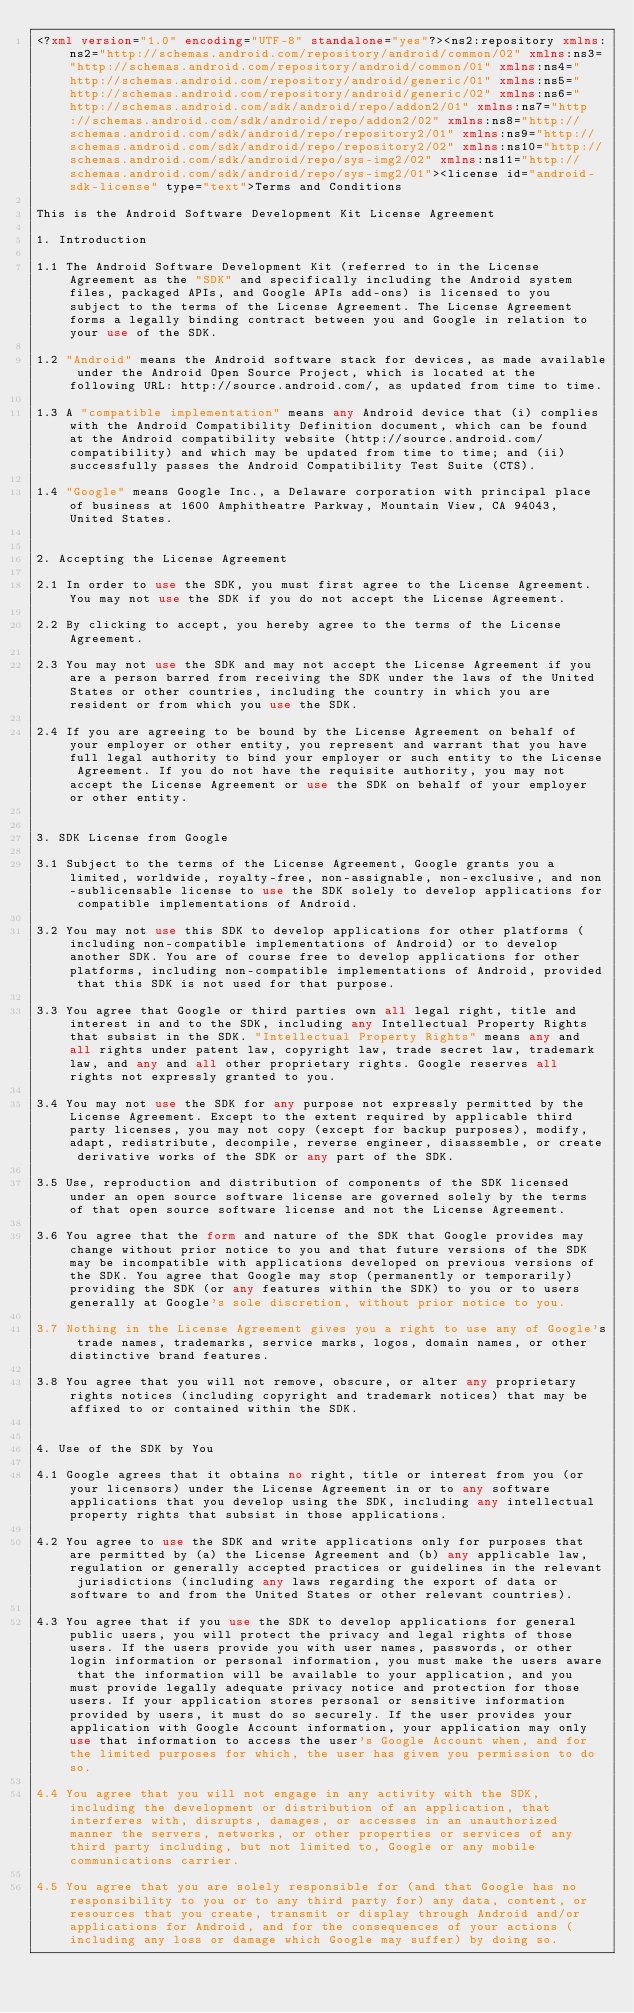Convert code to text. <code><loc_0><loc_0><loc_500><loc_500><_XML_><?xml version="1.0" encoding="UTF-8" standalone="yes"?><ns2:repository xmlns:ns2="http://schemas.android.com/repository/android/common/02" xmlns:ns3="http://schemas.android.com/repository/android/common/01" xmlns:ns4="http://schemas.android.com/repository/android/generic/01" xmlns:ns5="http://schemas.android.com/repository/android/generic/02" xmlns:ns6="http://schemas.android.com/sdk/android/repo/addon2/01" xmlns:ns7="http://schemas.android.com/sdk/android/repo/addon2/02" xmlns:ns8="http://schemas.android.com/sdk/android/repo/repository2/01" xmlns:ns9="http://schemas.android.com/sdk/android/repo/repository2/02" xmlns:ns10="http://schemas.android.com/sdk/android/repo/sys-img2/02" xmlns:ns11="http://schemas.android.com/sdk/android/repo/sys-img2/01"><license id="android-sdk-license" type="text">Terms and Conditions

This is the Android Software Development Kit License Agreement

1. Introduction

1.1 The Android Software Development Kit (referred to in the License Agreement as the "SDK" and specifically including the Android system files, packaged APIs, and Google APIs add-ons) is licensed to you subject to the terms of the License Agreement. The License Agreement forms a legally binding contract between you and Google in relation to your use of the SDK.

1.2 "Android" means the Android software stack for devices, as made available under the Android Open Source Project, which is located at the following URL: http://source.android.com/, as updated from time to time.

1.3 A "compatible implementation" means any Android device that (i) complies with the Android Compatibility Definition document, which can be found at the Android compatibility website (http://source.android.com/compatibility) and which may be updated from time to time; and (ii) successfully passes the Android Compatibility Test Suite (CTS).

1.4 "Google" means Google Inc., a Delaware corporation with principal place of business at 1600 Amphitheatre Parkway, Mountain View, CA 94043, United States.


2. Accepting the License Agreement

2.1 In order to use the SDK, you must first agree to the License Agreement. You may not use the SDK if you do not accept the License Agreement.

2.2 By clicking to accept, you hereby agree to the terms of the License Agreement.

2.3 You may not use the SDK and may not accept the License Agreement if you are a person barred from receiving the SDK under the laws of the United States or other countries, including the country in which you are resident or from which you use the SDK.

2.4 If you are agreeing to be bound by the License Agreement on behalf of your employer or other entity, you represent and warrant that you have full legal authority to bind your employer or such entity to the License Agreement. If you do not have the requisite authority, you may not accept the License Agreement or use the SDK on behalf of your employer or other entity.


3. SDK License from Google

3.1 Subject to the terms of the License Agreement, Google grants you a limited, worldwide, royalty-free, non-assignable, non-exclusive, and non-sublicensable license to use the SDK solely to develop applications for compatible implementations of Android.

3.2 You may not use this SDK to develop applications for other platforms (including non-compatible implementations of Android) or to develop another SDK. You are of course free to develop applications for other platforms, including non-compatible implementations of Android, provided that this SDK is not used for that purpose.

3.3 You agree that Google or third parties own all legal right, title and interest in and to the SDK, including any Intellectual Property Rights that subsist in the SDK. "Intellectual Property Rights" means any and all rights under patent law, copyright law, trade secret law, trademark law, and any and all other proprietary rights. Google reserves all rights not expressly granted to you.

3.4 You may not use the SDK for any purpose not expressly permitted by the License Agreement. Except to the extent required by applicable third party licenses, you may not copy (except for backup purposes), modify, adapt, redistribute, decompile, reverse engineer, disassemble, or create derivative works of the SDK or any part of the SDK.

3.5 Use, reproduction and distribution of components of the SDK licensed under an open source software license are governed solely by the terms of that open source software license and not the License Agreement.

3.6 You agree that the form and nature of the SDK that Google provides may change without prior notice to you and that future versions of the SDK may be incompatible with applications developed on previous versions of the SDK. You agree that Google may stop (permanently or temporarily) providing the SDK (or any features within the SDK) to you or to users generally at Google's sole discretion, without prior notice to you.

3.7 Nothing in the License Agreement gives you a right to use any of Google's trade names, trademarks, service marks, logos, domain names, or other distinctive brand features.

3.8 You agree that you will not remove, obscure, or alter any proprietary rights notices (including copyright and trademark notices) that may be affixed to or contained within the SDK.


4. Use of the SDK by You

4.1 Google agrees that it obtains no right, title or interest from you (or your licensors) under the License Agreement in or to any software applications that you develop using the SDK, including any intellectual property rights that subsist in those applications.

4.2 You agree to use the SDK and write applications only for purposes that are permitted by (a) the License Agreement and (b) any applicable law, regulation or generally accepted practices or guidelines in the relevant jurisdictions (including any laws regarding the export of data or software to and from the United States or other relevant countries).

4.3 You agree that if you use the SDK to develop applications for general public users, you will protect the privacy and legal rights of those users. If the users provide you with user names, passwords, or other login information or personal information, you must make the users aware that the information will be available to your application, and you must provide legally adequate privacy notice and protection for those users. If your application stores personal or sensitive information provided by users, it must do so securely. If the user provides your application with Google Account information, your application may only use that information to access the user's Google Account when, and for the limited purposes for which, the user has given you permission to do so.

4.4 You agree that you will not engage in any activity with the SDK, including the development or distribution of an application, that interferes with, disrupts, damages, or accesses in an unauthorized manner the servers, networks, or other properties or services of any third party including, but not limited to, Google or any mobile communications carrier.

4.5 You agree that you are solely responsible for (and that Google has no responsibility to you or to any third party for) any data, content, or resources that you create, transmit or display through Android and/or applications for Android, and for the consequences of your actions (including any loss or damage which Google may suffer) by doing so.
</code> 